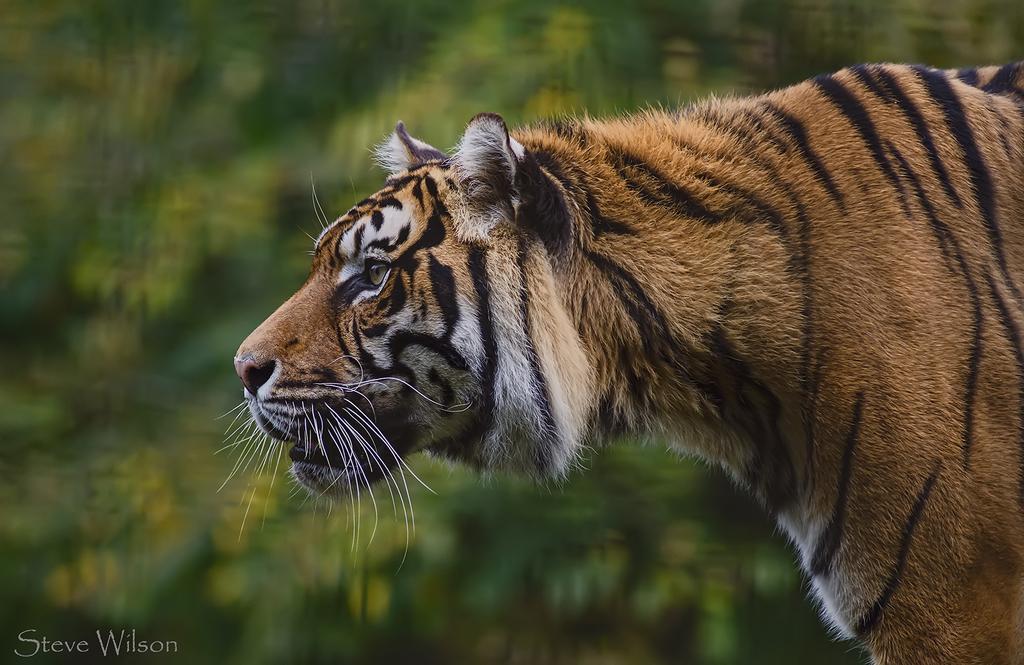How would you summarize this image in a sentence or two? In this image we can see an Indian tiger which is of brown color and at the background of the image there are some trees. 